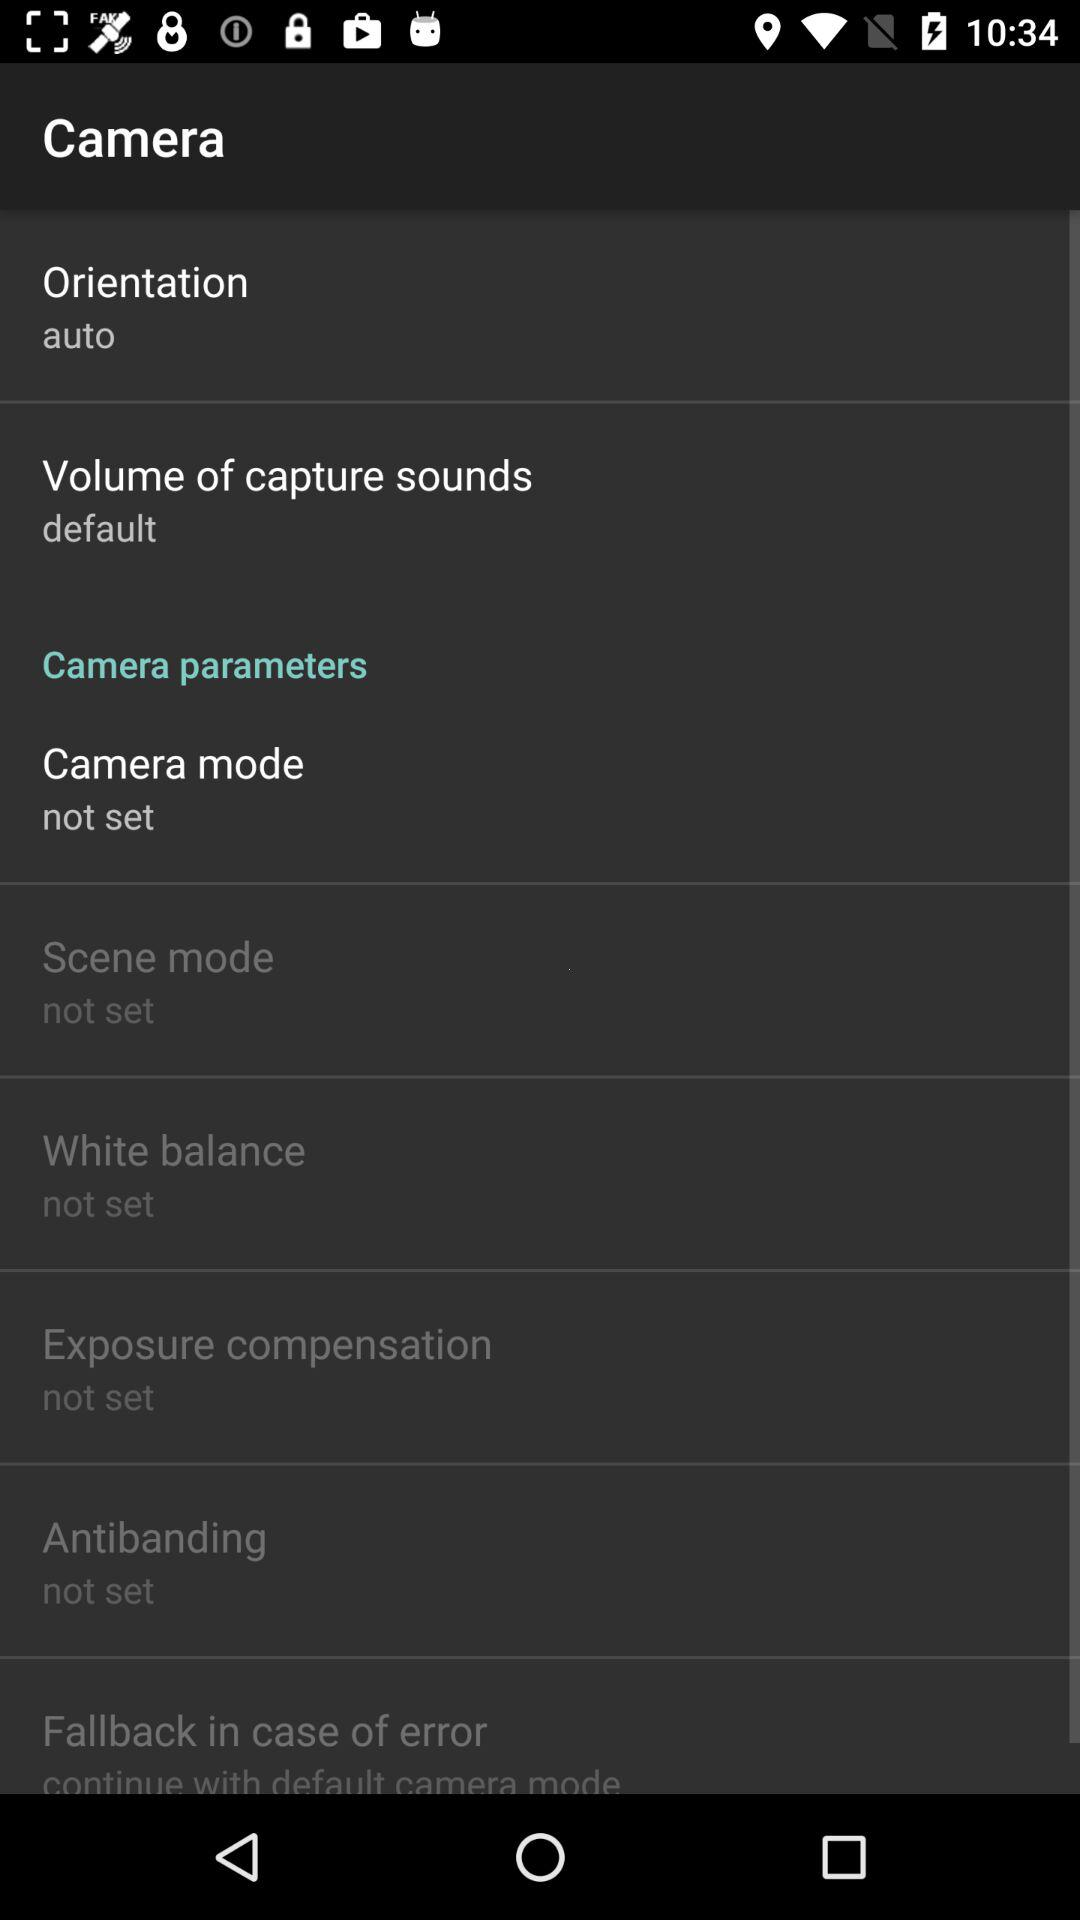What is the setting for the "Volume of capture sounds"? The setting is "default". 